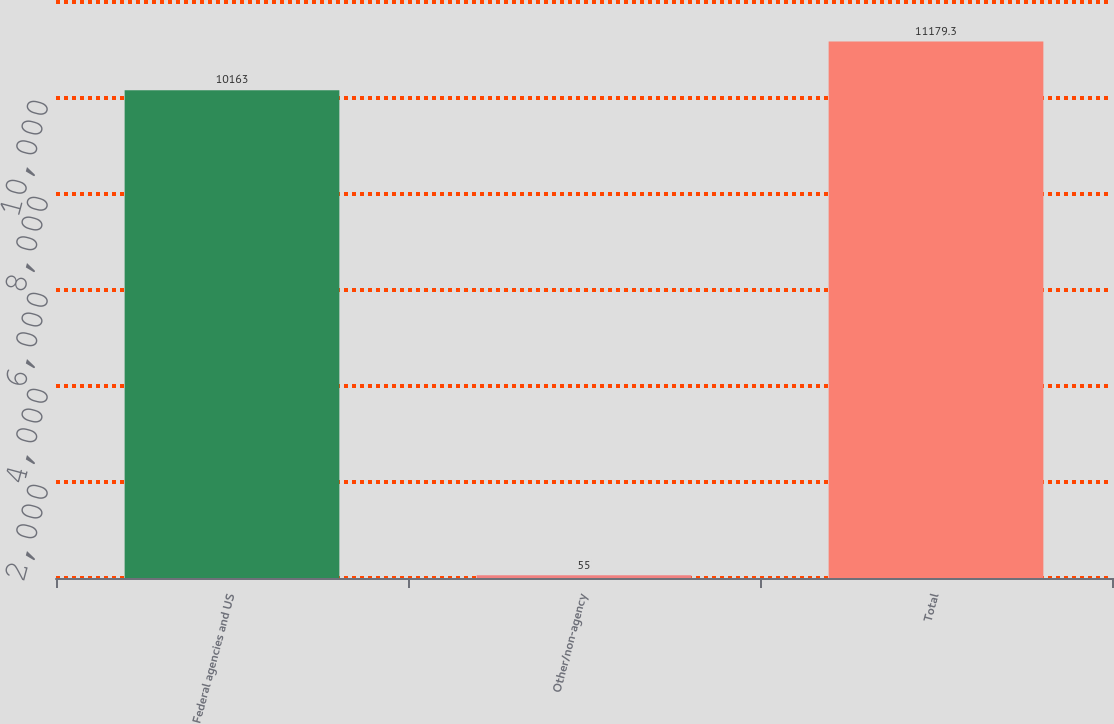Convert chart to OTSL. <chart><loc_0><loc_0><loc_500><loc_500><bar_chart><fcel>Federal agencies and US<fcel>Other/non-agency<fcel>Total<nl><fcel>10163<fcel>55<fcel>11179.3<nl></chart> 